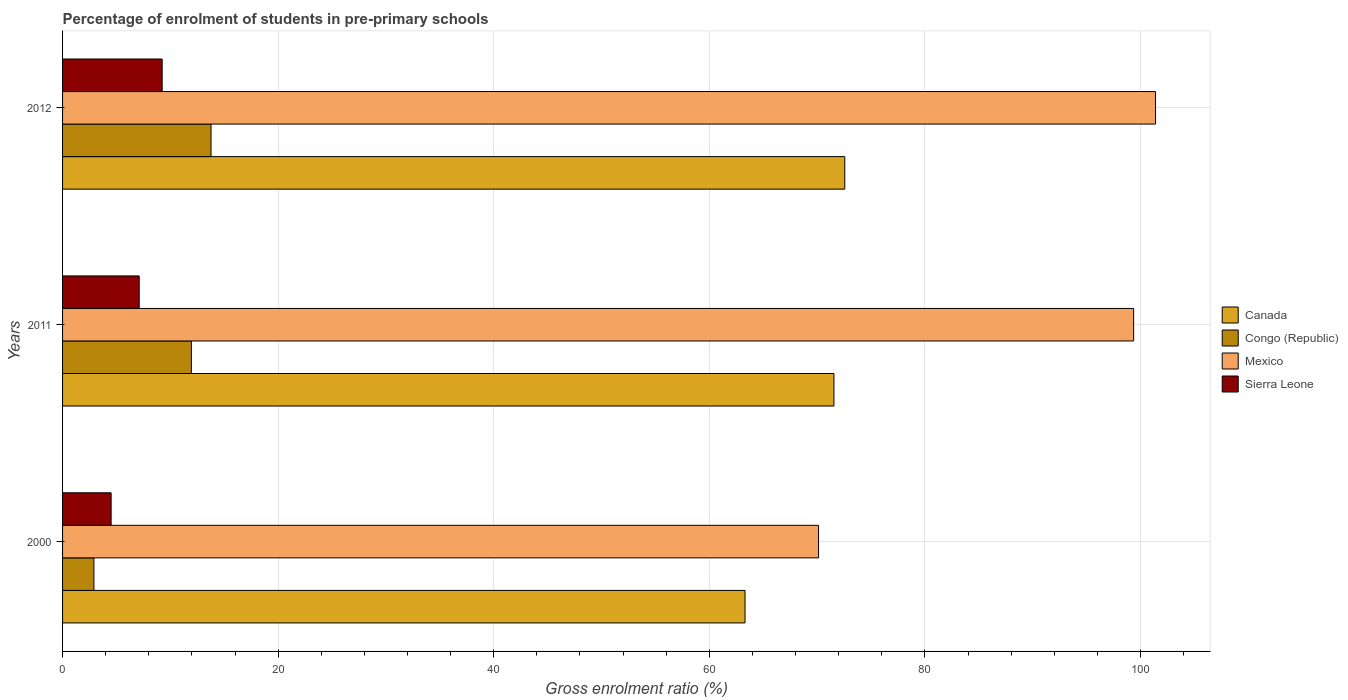How many different coloured bars are there?
Offer a very short reply. 4. How many groups of bars are there?
Your answer should be very brief. 3. Are the number of bars on each tick of the Y-axis equal?
Your answer should be compact. Yes. How many bars are there on the 3rd tick from the bottom?
Your answer should be compact. 4. What is the label of the 3rd group of bars from the top?
Your response must be concise. 2000. In how many cases, is the number of bars for a given year not equal to the number of legend labels?
Keep it short and to the point. 0. What is the percentage of students enrolled in pre-primary schools in Mexico in 2011?
Provide a short and direct response. 99.36. Across all years, what is the maximum percentage of students enrolled in pre-primary schools in Mexico?
Your response must be concise. 101.39. Across all years, what is the minimum percentage of students enrolled in pre-primary schools in Mexico?
Your answer should be very brief. 70.13. In which year was the percentage of students enrolled in pre-primary schools in Mexico maximum?
Your answer should be compact. 2012. What is the total percentage of students enrolled in pre-primary schools in Congo (Republic) in the graph?
Your response must be concise. 28.63. What is the difference between the percentage of students enrolled in pre-primary schools in Congo (Republic) in 2011 and that in 2012?
Offer a very short reply. -1.82. What is the difference between the percentage of students enrolled in pre-primary schools in Congo (Republic) in 2000 and the percentage of students enrolled in pre-primary schools in Mexico in 2012?
Your answer should be very brief. -98.48. What is the average percentage of students enrolled in pre-primary schools in Canada per year?
Give a very brief answer. 69.14. In the year 2011, what is the difference between the percentage of students enrolled in pre-primary schools in Mexico and percentage of students enrolled in pre-primary schools in Sierra Leone?
Offer a very short reply. 92.25. What is the ratio of the percentage of students enrolled in pre-primary schools in Canada in 2000 to that in 2011?
Make the answer very short. 0.88. Is the percentage of students enrolled in pre-primary schools in Sierra Leone in 2011 less than that in 2012?
Your response must be concise. Yes. Is the difference between the percentage of students enrolled in pre-primary schools in Mexico in 2000 and 2012 greater than the difference between the percentage of students enrolled in pre-primary schools in Sierra Leone in 2000 and 2012?
Your response must be concise. No. What is the difference between the highest and the second highest percentage of students enrolled in pre-primary schools in Sierra Leone?
Your response must be concise. 2.13. What is the difference between the highest and the lowest percentage of students enrolled in pre-primary schools in Mexico?
Your answer should be very brief. 31.26. What does the 1st bar from the top in 2012 represents?
Offer a terse response. Sierra Leone. Is it the case that in every year, the sum of the percentage of students enrolled in pre-primary schools in Canada and percentage of students enrolled in pre-primary schools in Congo (Republic) is greater than the percentage of students enrolled in pre-primary schools in Sierra Leone?
Keep it short and to the point. Yes. Are all the bars in the graph horizontal?
Offer a terse response. Yes. How many years are there in the graph?
Your response must be concise. 3. Does the graph contain any zero values?
Give a very brief answer. No. Does the graph contain grids?
Your answer should be very brief. Yes. What is the title of the graph?
Offer a terse response. Percentage of enrolment of students in pre-primary schools. Does "Sint Maarten (Dutch part)" appear as one of the legend labels in the graph?
Make the answer very short. No. What is the label or title of the Y-axis?
Give a very brief answer. Years. What is the Gross enrolment ratio (%) in Canada in 2000?
Your answer should be very brief. 63.31. What is the Gross enrolment ratio (%) of Congo (Republic) in 2000?
Give a very brief answer. 2.91. What is the Gross enrolment ratio (%) in Mexico in 2000?
Your answer should be compact. 70.13. What is the Gross enrolment ratio (%) in Sierra Leone in 2000?
Offer a terse response. 4.5. What is the Gross enrolment ratio (%) of Canada in 2011?
Ensure brevity in your answer.  71.56. What is the Gross enrolment ratio (%) in Congo (Republic) in 2011?
Keep it short and to the point. 11.95. What is the Gross enrolment ratio (%) of Mexico in 2011?
Your answer should be very brief. 99.36. What is the Gross enrolment ratio (%) of Sierra Leone in 2011?
Provide a succinct answer. 7.11. What is the Gross enrolment ratio (%) of Canada in 2012?
Provide a succinct answer. 72.56. What is the Gross enrolment ratio (%) in Congo (Republic) in 2012?
Keep it short and to the point. 13.77. What is the Gross enrolment ratio (%) of Mexico in 2012?
Offer a terse response. 101.39. What is the Gross enrolment ratio (%) in Sierra Leone in 2012?
Keep it short and to the point. 9.24. Across all years, what is the maximum Gross enrolment ratio (%) of Canada?
Your answer should be compact. 72.56. Across all years, what is the maximum Gross enrolment ratio (%) of Congo (Republic)?
Provide a succinct answer. 13.77. Across all years, what is the maximum Gross enrolment ratio (%) of Mexico?
Offer a very short reply. 101.39. Across all years, what is the maximum Gross enrolment ratio (%) in Sierra Leone?
Offer a very short reply. 9.24. Across all years, what is the minimum Gross enrolment ratio (%) in Canada?
Your response must be concise. 63.31. Across all years, what is the minimum Gross enrolment ratio (%) in Congo (Republic)?
Make the answer very short. 2.91. Across all years, what is the minimum Gross enrolment ratio (%) of Mexico?
Keep it short and to the point. 70.13. Across all years, what is the minimum Gross enrolment ratio (%) of Sierra Leone?
Provide a short and direct response. 4.5. What is the total Gross enrolment ratio (%) of Canada in the graph?
Provide a succinct answer. 207.43. What is the total Gross enrolment ratio (%) in Congo (Republic) in the graph?
Offer a very short reply. 28.63. What is the total Gross enrolment ratio (%) in Mexico in the graph?
Make the answer very short. 270.88. What is the total Gross enrolment ratio (%) in Sierra Leone in the graph?
Make the answer very short. 20.85. What is the difference between the Gross enrolment ratio (%) in Canada in 2000 and that in 2011?
Give a very brief answer. -8.25. What is the difference between the Gross enrolment ratio (%) in Congo (Republic) in 2000 and that in 2011?
Keep it short and to the point. -9.04. What is the difference between the Gross enrolment ratio (%) of Mexico in 2000 and that in 2011?
Ensure brevity in your answer.  -29.23. What is the difference between the Gross enrolment ratio (%) in Sierra Leone in 2000 and that in 2011?
Your answer should be compact. -2.6. What is the difference between the Gross enrolment ratio (%) in Canada in 2000 and that in 2012?
Offer a very short reply. -9.25. What is the difference between the Gross enrolment ratio (%) of Congo (Republic) in 2000 and that in 2012?
Provide a short and direct response. -10.86. What is the difference between the Gross enrolment ratio (%) in Mexico in 2000 and that in 2012?
Make the answer very short. -31.26. What is the difference between the Gross enrolment ratio (%) in Sierra Leone in 2000 and that in 2012?
Your answer should be very brief. -4.74. What is the difference between the Gross enrolment ratio (%) of Canada in 2011 and that in 2012?
Provide a short and direct response. -1. What is the difference between the Gross enrolment ratio (%) in Congo (Republic) in 2011 and that in 2012?
Keep it short and to the point. -1.82. What is the difference between the Gross enrolment ratio (%) in Mexico in 2011 and that in 2012?
Your response must be concise. -2.03. What is the difference between the Gross enrolment ratio (%) in Sierra Leone in 2011 and that in 2012?
Your response must be concise. -2.13. What is the difference between the Gross enrolment ratio (%) of Canada in 2000 and the Gross enrolment ratio (%) of Congo (Republic) in 2011?
Offer a very short reply. 51.36. What is the difference between the Gross enrolment ratio (%) in Canada in 2000 and the Gross enrolment ratio (%) in Mexico in 2011?
Provide a succinct answer. -36.05. What is the difference between the Gross enrolment ratio (%) of Canada in 2000 and the Gross enrolment ratio (%) of Sierra Leone in 2011?
Ensure brevity in your answer.  56.2. What is the difference between the Gross enrolment ratio (%) in Congo (Republic) in 2000 and the Gross enrolment ratio (%) in Mexico in 2011?
Provide a short and direct response. -96.45. What is the difference between the Gross enrolment ratio (%) of Congo (Republic) in 2000 and the Gross enrolment ratio (%) of Sierra Leone in 2011?
Your response must be concise. -4.2. What is the difference between the Gross enrolment ratio (%) in Mexico in 2000 and the Gross enrolment ratio (%) in Sierra Leone in 2011?
Offer a terse response. 63.02. What is the difference between the Gross enrolment ratio (%) in Canada in 2000 and the Gross enrolment ratio (%) in Congo (Republic) in 2012?
Provide a succinct answer. 49.54. What is the difference between the Gross enrolment ratio (%) in Canada in 2000 and the Gross enrolment ratio (%) in Mexico in 2012?
Ensure brevity in your answer.  -38.08. What is the difference between the Gross enrolment ratio (%) of Canada in 2000 and the Gross enrolment ratio (%) of Sierra Leone in 2012?
Give a very brief answer. 54.07. What is the difference between the Gross enrolment ratio (%) in Congo (Republic) in 2000 and the Gross enrolment ratio (%) in Mexico in 2012?
Offer a terse response. -98.48. What is the difference between the Gross enrolment ratio (%) in Congo (Republic) in 2000 and the Gross enrolment ratio (%) in Sierra Leone in 2012?
Provide a succinct answer. -6.33. What is the difference between the Gross enrolment ratio (%) in Mexico in 2000 and the Gross enrolment ratio (%) in Sierra Leone in 2012?
Ensure brevity in your answer.  60.89. What is the difference between the Gross enrolment ratio (%) of Canada in 2011 and the Gross enrolment ratio (%) of Congo (Republic) in 2012?
Ensure brevity in your answer.  57.79. What is the difference between the Gross enrolment ratio (%) of Canada in 2011 and the Gross enrolment ratio (%) of Mexico in 2012?
Make the answer very short. -29.83. What is the difference between the Gross enrolment ratio (%) of Canada in 2011 and the Gross enrolment ratio (%) of Sierra Leone in 2012?
Your response must be concise. 62.32. What is the difference between the Gross enrolment ratio (%) in Congo (Republic) in 2011 and the Gross enrolment ratio (%) in Mexico in 2012?
Your answer should be compact. -89.44. What is the difference between the Gross enrolment ratio (%) in Congo (Republic) in 2011 and the Gross enrolment ratio (%) in Sierra Leone in 2012?
Your answer should be very brief. 2.71. What is the difference between the Gross enrolment ratio (%) of Mexico in 2011 and the Gross enrolment ratio (%) of Sierra Leone in 2012?
Your answer should be very brief. 90.12. What is the average Gross enrolment ratio (%) in Canada per year?
Give a very brief answer. 69.14. What is the average Gross enrolment ratio (%) in Congo (Republic) per year?
Your answer should be compact. 9.54. What is the average Gross enrolment ratio (%) in Mexico per year?
Provide a succinct answer. 90.29. What is the average Gross enrolment ratio (%) in Sierra Leone per year?
Keep it short and to the point. 6.95. In the year 2000, what is the difference between the Gross enrolment ratio (%) in Canada and Gross enrolment ratio (%) in Congo (Republic)?
Make the answer very short. 60.4. In the year 2000, what is the difference between the Gross enrolment ratio (%) in Canada and Gross enrolment ratio (%) in Mexico?
Provide a succinct answer. -6.82. In the year 2000, what is the difference between the Gross enrolment ratio (%) in Canada and Gross enrolment ratio (%) in Sierra Leone?
Ensure brevity in your answer.  58.81. In the year 2000, what is the difference between the Gross enrolment ratio (%) in Congo (Republic) and Gross enrolment ratio (%) in Mexico?
Offer a very short reply. -67.22. In the year 2000, what is the difference between the Gross enrolment ratio (%) in Congo (Republic) and Gross enrolment ratio (%) in Sierra Leone?
Your answer should be very brief. -1.6. In the year 2000, what is the difference between the Gross enrolment ratio (%) of Mexico and Gross enrolment ratio (%) of Sierra Leone?
Provide a succinct answer. 65.63. In the year 2011, what is the difference between the Gross enrolment ratio (%) of Canada and Gross enrolment ratio (%) of Congo (Republic)?
Provide a short and direct response. 59.61. In the year 2011, what is the difference between the Gross enrolment ratio (%) of Canada and Gross enrolment ratio (%) of Mexico?
Make the answer very short. -27.8. In the year 2011, what is the difference between the Gross enrolment ratio (%) in Canada and Gross enrolment ratio (%) in Sierra Leone?
Your answer should be very brief. 64.45. In the year 2011, what is the difference between the Gross enrolment ratio (%) in Congo (Republic) and Gross enrolment ratio (%) in Mexico?
Give a very brief answer. -87.41. In the year 2011, what is the difference between the Gross enrolment ratio (%) in Congo (Republic) and Gross enrolment ratio (%) in Sierra Leone?
Give a very brief answer. 4.84. In the year 2011, what is the difference between the Gross enrolment ratio (%) in Mexico and Gross enrolment ratio (%) in Sierra Leone?
Your answer should be compact. 92.25. In the year 2012, what is the difference between the Gross enrolment ratio (%) of Canada and Gross enrolment ratio (%) of Congo (Republic)?
Make the answer very short. 58.79. In the year 2012, what is the difference between the Gross enrolment ratio (%) in Canada and Gross enrolment ratio (%) in Mexico?
Your response must be concise. -28.83. In the year 2012, what is the difference between the Gross enrolment ratio (%) in Canada and Gross enrolment ratio (%) in Sierra Leone?
Give a very brief answer. 63.32. In the year 2012, what is the difference between the Gross enrolment ratio (%) of Congo (Republic) and Gross enrolment ratio (%) of Mexico?
Ensure brevity in your answer.  -87.62. In the year 2012, what is the difference between the Gross enrolment ratio (%) of Congo (Republic) and Gross enrolment ratio (%) of Sierra Leone?
Your answer should be very brief. 4.53. In the year 2012, what is the difference between the Gross enrolment ratio (%) in Mexico and Gross enrolment ratio (%) in Sierra Leone?
Provide a short and direct response. 92.15. What is the ratio of the Gross enrolment ratio (%) of Canada in 2000 to that in 2011?
Offer a terse response. 0.88. What is the ratio of the Gross enrolment ratio (%) in Congo (Republic) in 2000 to that in 2011?
Your response must be concise. 0.24. What is the ratio of the Gross enrolment ratio (%) in Mexico in 2000 to that in 2011?
Your answer should be very brief. 0.71. What is the ratio of the Gross enrolment ratio (%) of Sierra Leone in 2000 to that in 2011?
Ensure brevity in your answer.  0.63. What is the ratio of the Gross enrolment ratio (%) of Canada in 2000 to that in 2012?
Make the answer very short. 0.87. What is the ratio of the Gross enrolment ratio (%) of Congo (Republic) in 2000 to that in 2012?
Your answer should be very brief. 0.21. What is the ratio of the Gross enrolment ratio (%) in Mexico in 2000 to that in 2012?
Keep it short and to the point. 0.69. What is the ratio of the Gross enrolment ratio (%) in Sierra Leone in 2000 to that in 2012?
Keep it short and to the point. 0.49. What is the ratio of the Gross enrolment ratio (%) in Canada in 2011 to that in 2012?
Offer a terse response. 0.99. What is the ratio of the Gross enrolment ratio (%) in Congo (Republic) in 2011 to that in 2012?
Give a very brief answer. 0.87. What is the ratio of the Gross enrolment ratio (%) in Mexico in 2011 to that in 2012?
Your answer should be compact. 0.98. What is the ratio of the Gross enrolment ratio (%) of Sierra Leone in 2011 to that in 2012?
Your answer should be compact. 0.77. What is the difference between the highest and the second highest Gross enrolment ratio (%) of Canada?
Make the answer very short. 1. What is the difference between the highest and the second highest Gross enrolment ratio (%) of Congo (Republic)?
Offer a terse response. 1.82. What is the difference between the highest and the second highest Gross enrolment ratio (%) in Mexico?
Keep it short and to the point. 2.03. What is the difference between the highest and the second highest Gross enrolment ratio (%) in Sierra Leone?
Keep it short and to the point. 2.13. What is the difference between the highest and the lowest Gross enrolment ratio (%) of Canada?
Your answer should be very brief. 9.25. What is the difference between the highest and the lowest Gross enrolment ratio (%) of Congo (Republic)?
Your response must be concise. 10.86. What is the difference between the highest and the lowest Gross enrolment ratio (%) of Mexico?
Offer a terse response. 31.26. What is the difference between the highest and the lowest Gross enrolment ratio (%) in Sierra Leone?
Your response must be concise. 4.74. 